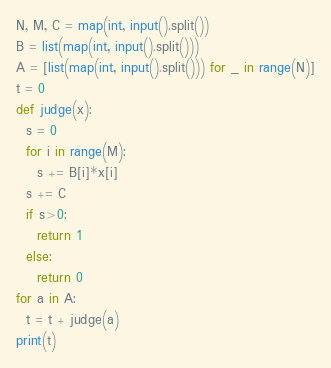Convert code to text. <code><loc_0><loc_0><loc_500><loc_500><_Python_>N, M, C = map(int, input().split())
B = list(map(int, input().split()))
A = [list(map(int, input().split())) for _ in range(N)]
t = 0
def judge(x):
  s = 0
  for i in range(M):
    s += B[i]*x[i]
  s += C
  if s>0:
    return 1
  else:
    return 0
for a in A:
  t = t + judge(a)
print(t)</code> 